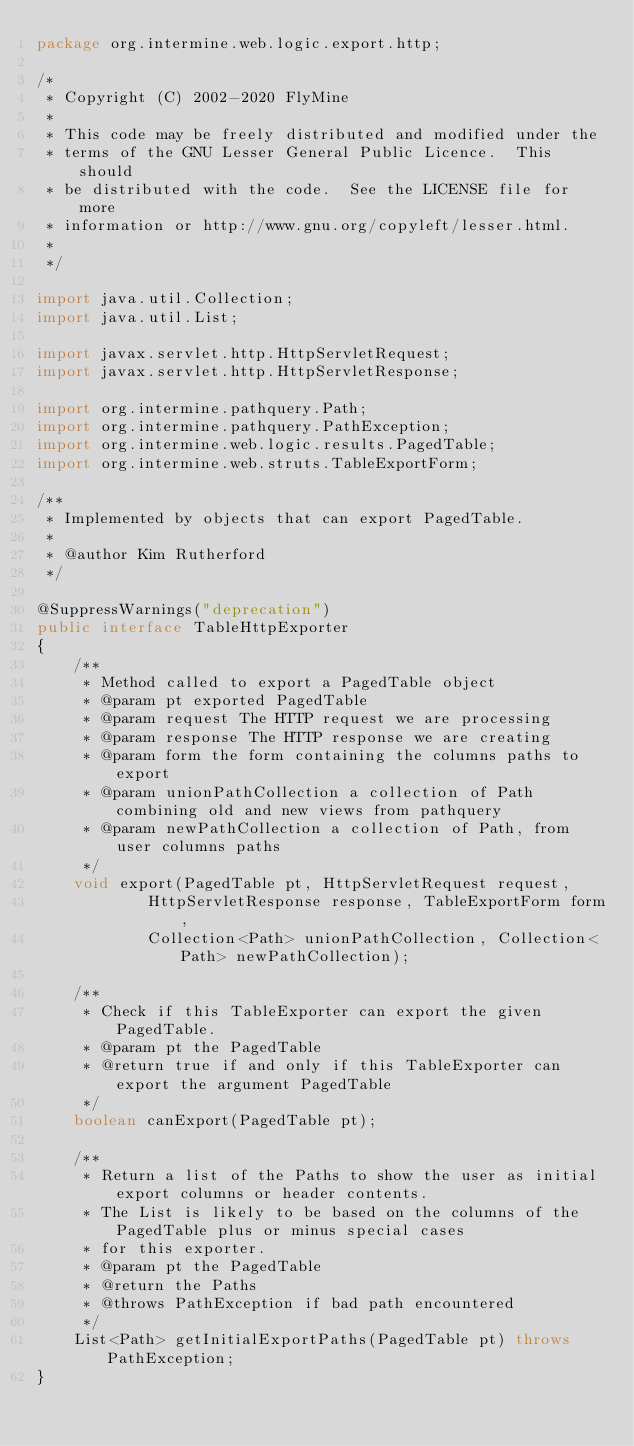Convert code to text. <code><loc_0><loc_0><loc_500><loc_500><_Java_>package org.intermine.web.logic.export.http;

/*
 * Copyright (C) 2002-2020 FlyMine
 *
 * This code may be freely distributed and modified under the
 * terms of the GNU Lesser General Public Licence.  This should
 * be distributed with the code.  See the LICENSE file for more
 * information or http://www.gnu.org/copyleft/lesser.html.
 *
 */

import java.util.Collection;
import java.util.List;

import javax.servlet.http.HttpServletRequest;
import javax.servlet.http.HttpServletResponse;

import org.intermine.pathquery.Path;
import org.intermine.pathquery.PathException;
import org.intermine.web.logic.results.PagedTable;
import org.intermine.web.struts.TableExportForm;

/**
 * Implemented by objects that can export PagedTable.
 *
 * @author Kim Rutherford
 */

@SuppressWarnings("deprecation")
public interface TableHttpExporter
{
    /**
     * Method called to export a PagedTable object
     * @param pt exported PagedTable
     * @param request The HTTP request we are processing
     * @param response The HTTP response we are creating
     * @param form the form containing the columns paths to export
     * @param unionPathCollection a collection of Path combining old and new views from pathquery
     * @param newPathCollection a collection of Path, from user columns paths
     */
    void export(PagedTable pt, HttpServletRequest request,
            HttpServletResponse response, TableExportForm form,
            Collection<Path> unionPathCollection, Collection<Path> newPathCollection);

    /**
     * Check if this TableExporter can export the given PagedTable.
     * @param pt the PagedTable
     * @return true if and only if this TableExporter can export the argument PagedTable
     */
    boolean canExport(PagedTable pt);

    /**
     * Return a list of the Paths to show the user as initial export columns or header contents.
     * The List is likely to be based on the columns of the PagedTable plus or minus special cases
     * for this exporter.
     * @param pt the PagedTable
     * @return the Paths
     * @throws PathException if bad path encountered
     */
    List<Path> getInitialExportPaths(PagedTable pt) throws PathException;
}
</code> 